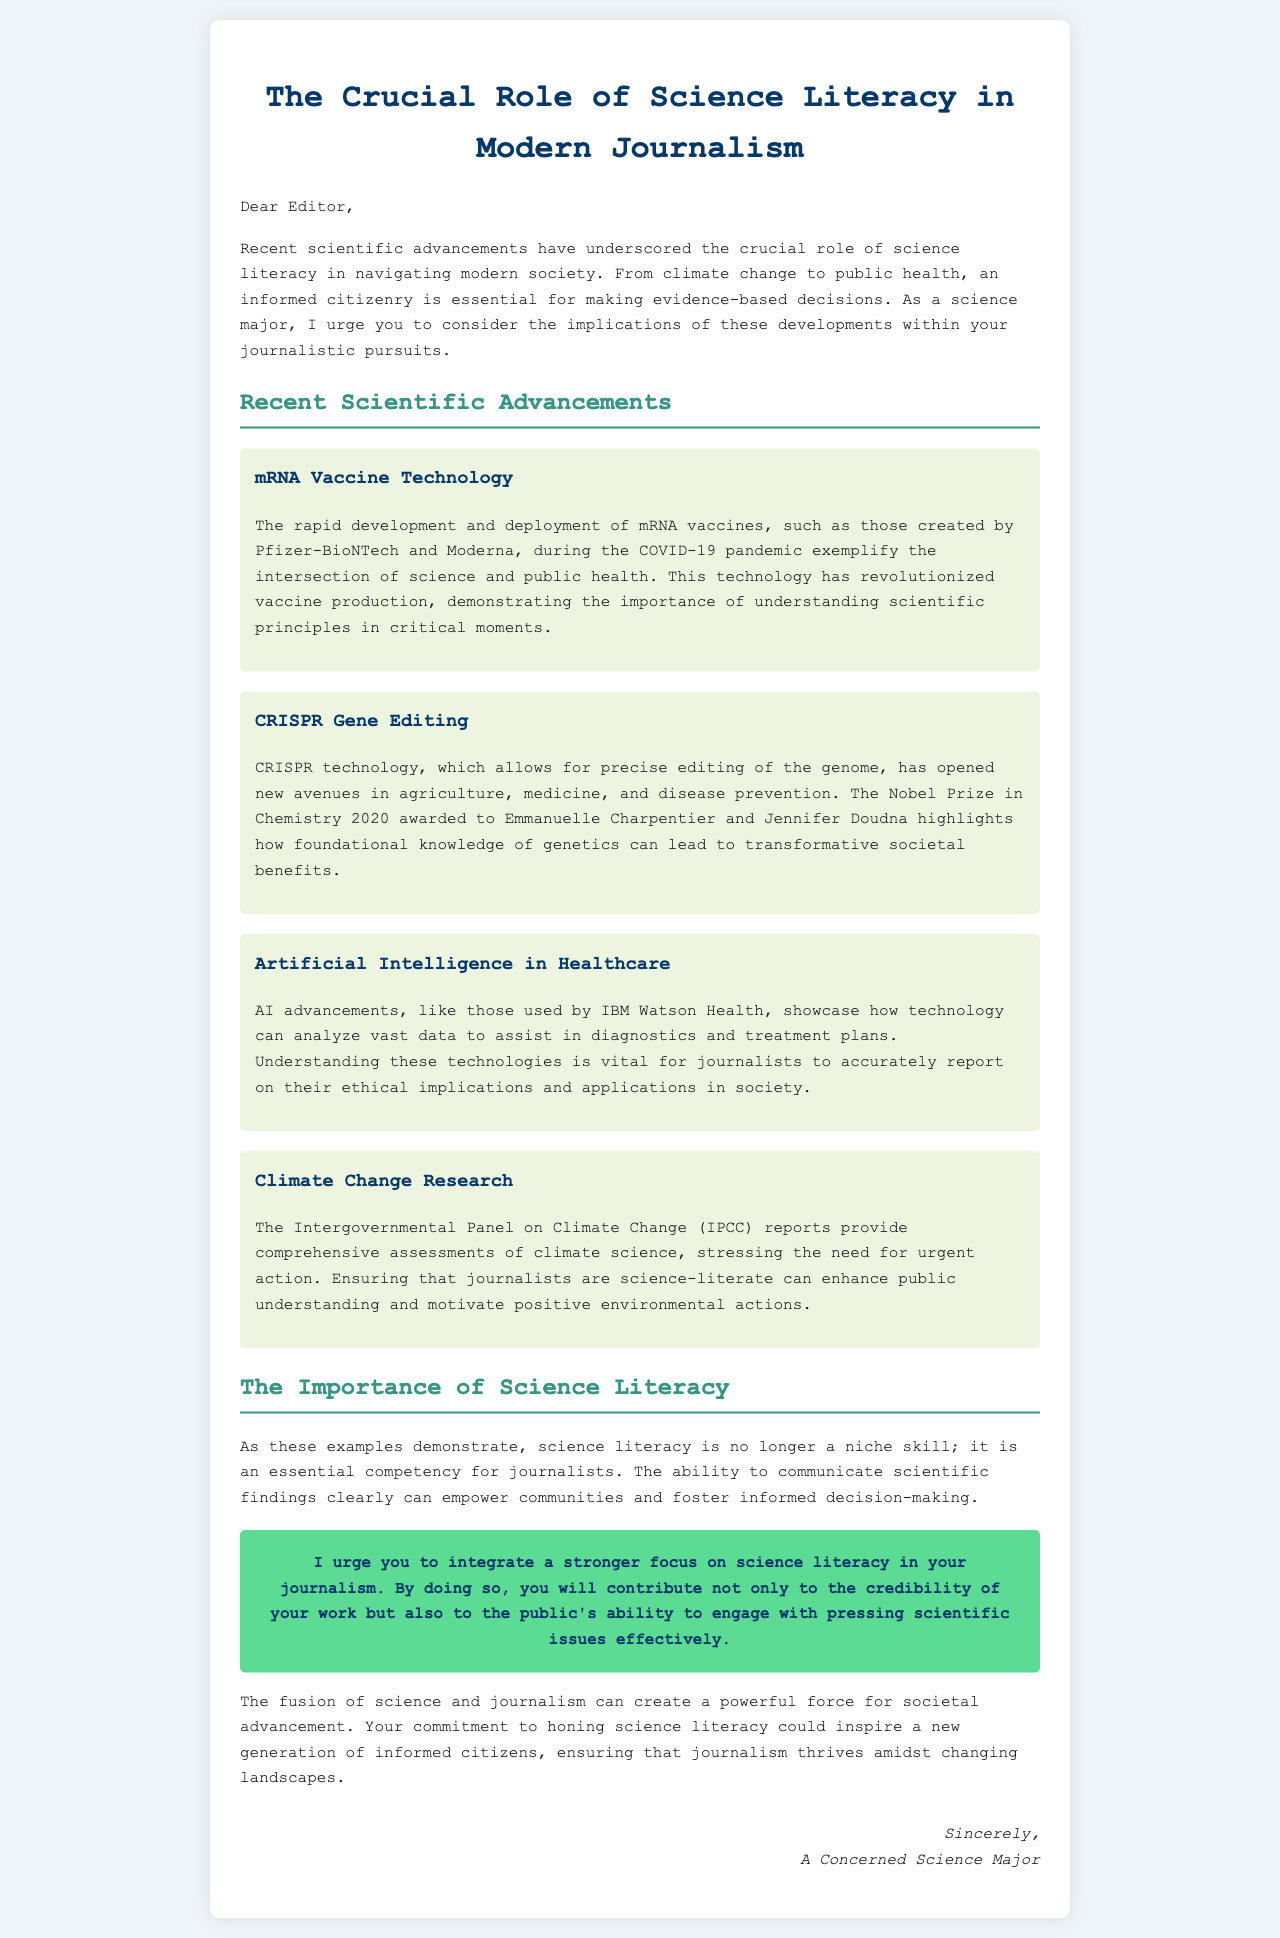what is the title of the document? The title is the main heading of the document, presented prominently at the top.
Answer: The Crucial Role of Science Literacy in Modern Journalism who are the recipients of the letter? The recipients are mentioned directly in the salutation at the beginning of the letter.
Answer: Editor what scientific technology is highlighted for its role in public health? This technology is specified in the section discussing recent advancements in relation to public health.
Answer: mRNA Vaccine Technology which Nobel Prize winners are mentioned in the letter? The letter includes the names of recipients of the Nobel Prize in Chemistry related to CRISPR technology.
Answer: Emmanuelle Charpentier and Jennifer Doudna what is the primary call to action for journalists in the document? The document includes a specific statement urging journalists to enhance a particular skill or focus.
Answer: Integrate a stronger focus on science literacy how does the author view the relationship between science and journalism? The author's perspective is expressed in a sentence discussing the fusion of these two fields and its potential outcome.
Answer: A powerful force for societal advancement what specific AI use case is mentioned in the document? The document details an example of how AI is being applied in a particular field.
Answer: Healthcare what is one of the scientific areas that journalists need to understand according to the letter? The letter identifies several areas; one of them is explicitly mentioned in the context of climate change.
Answer: Climate Change Research how many advancements are discussed in the letter? This can be determined by counting the number of sections labeled as advancements.
Answer: Four 